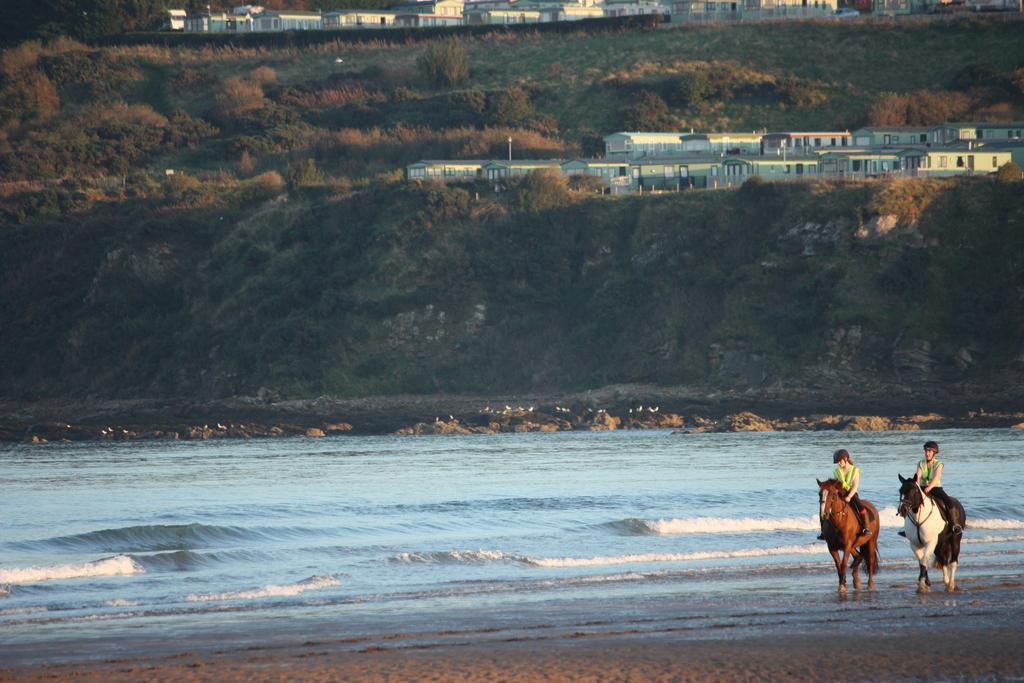Could you give a brief overview of what you see in this image? In the image there are two persons riding horse in front of the beach and behind it there is hill with many buildings on it. 